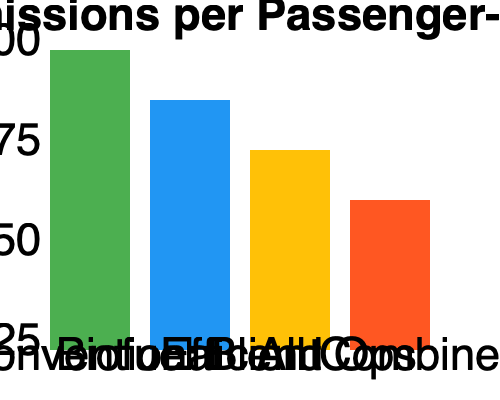Based on the comparative bar graph showing CO₂ emissions per passenger-mile for different air travel scenarios, what combination of strategies would result in the greatest reduction of environmental impact while maintaining operational efficiency? To answer this question, we need to analyze the data presented in the bar graph:

1. Conventional air travel: This serves as our baseline, showing the highest CO₂ emissions per passenger-mile.

2. Biofuel Blend: The second bar shows a reduction in emissions compared to conventional fuel, indicating that using biofuel blends can help reduce the environmental impact.

3. Efficient Operations: The third bar shows an even greater reduction in emissions, suggesting that optimizing flight operations (e.g., route planning, weight reduction, improved aerodynamics) can significantly decrease CO₂ emissions.

4. All Combined: The last bar represents the combination of biofuel blends and efficient operations, showing the lowest emissions per passenger-mile.

To minimize environmental impact while maintaining operational efficiency, we should focus on:

a) Implementing efficient operations, as this shows the most significant individual reduction in emissions.
b) Incorporating biofuel blends into our fuel mix, which provides an additional reduction in emissions.
c) Combining both strategies (efficient operations and biofuel blends) to achieve the maximum possible reduction in CO₂ emissions per passenger-mile.

The graph clearly shows that the combination of all strategies (biofuel blends and efficient operations) results in the lowest emissions, making it the most environmentally friendly option while still maintaining operational viability.
Answer: Combine efficient operations with biofuel blends 